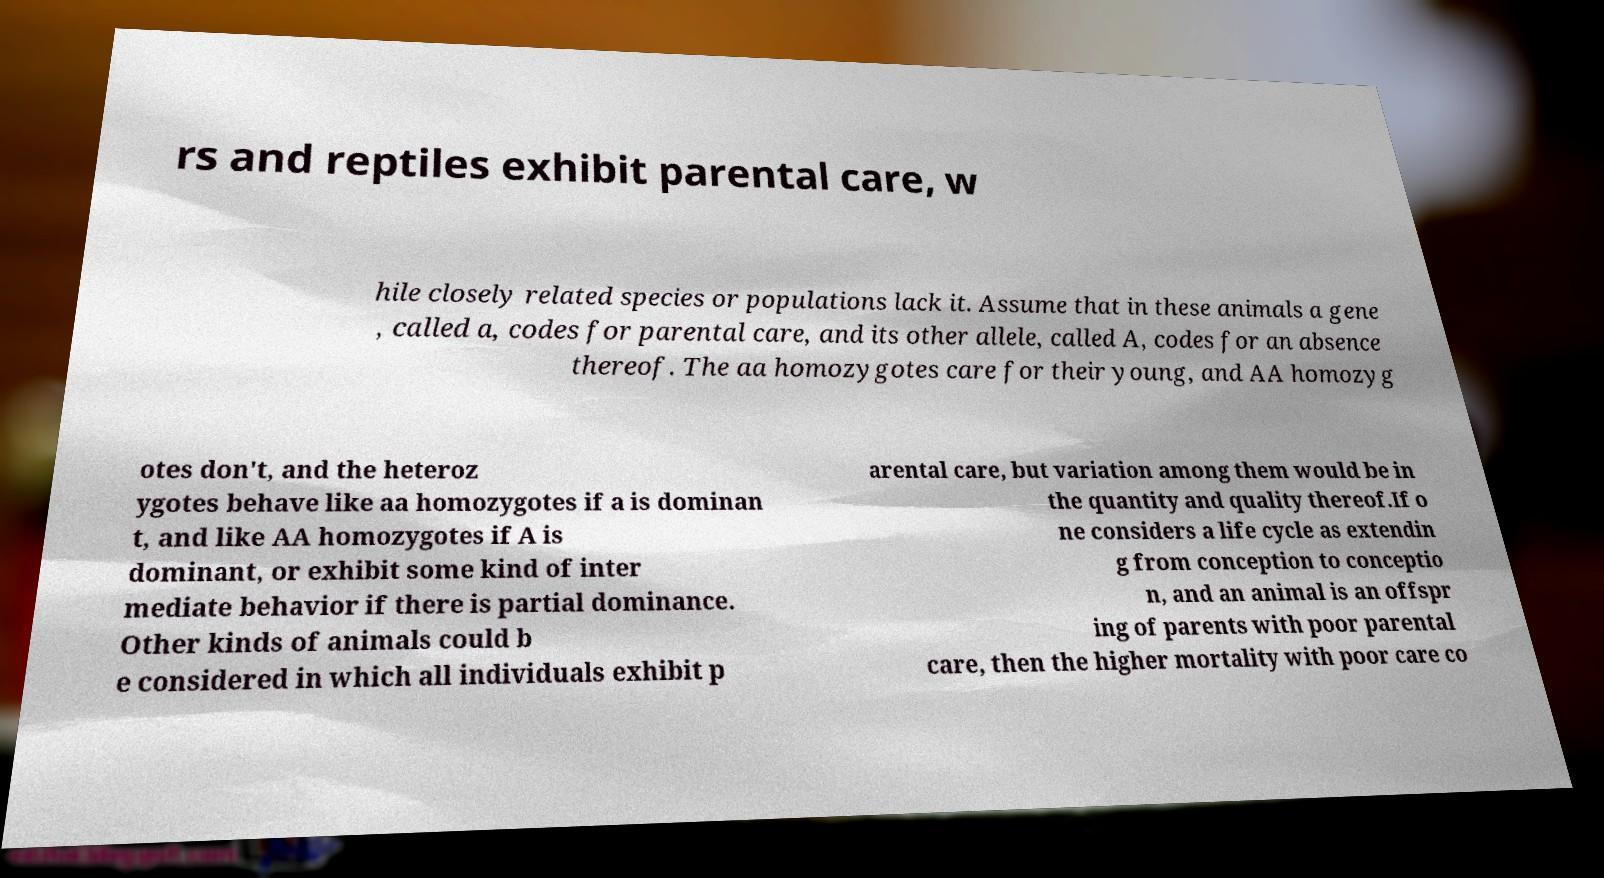What messages or text are displayed in this image? I need them in a readable, typed format. rs and reptiles exhibit parental care, w hile closely related species or populations lack it. Assume that in these animals a gene , called a, codes for parental care, and its other allele, called A, codes for an absence thereof. The aa homozygotes care for their young, and AA homozyg otes don't, and the heteroz ygotes behave like aa homozygotes if a is dominan t, and like AA homozygotes if A is dominant, or exhibit some kind of inter mediate behavior if there is partial dominance. Other kinds of animals could b e considered in which all individuals exhibit p arental care, but variation among them would be in the quantity and quality thereof.If o ne considers a life cycle as extendin g from conception to conceptio n, and an animal is an offspr ing of parents with poor parental care, then the higher mortality with poor care co 